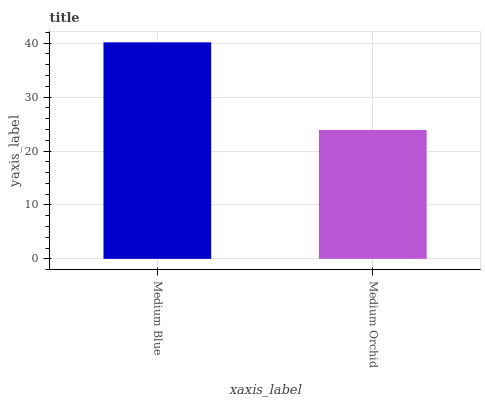Is Medium Orchid the minimum?
Answer yes or no. Yes. Is Medium Blue the maximum?
Answer yes or no. Yes. Is Medium Orchid the maximum?
Answer yes or no. No. Is Medium Blue greater than Medium Orchid?
Answer yes or no. Yes. Is Medium Orchid less than Medium Blue?
Answer yes or no. Yes. Is Medium Orchid greater than Medium Blue?
Answer yes or no. No. Is Medium Blue less than Medium Orchid?
Answer yes or no. No. Is Medium Blue the high median?
Answer yes or no. Yes. Is Medium Orchid the low median?
Answer yes or no. Yes. Is Medium Orchid the high median?
Answer yes or no. No. Is Medium Blue the low median?
Answer yes or no. No. 